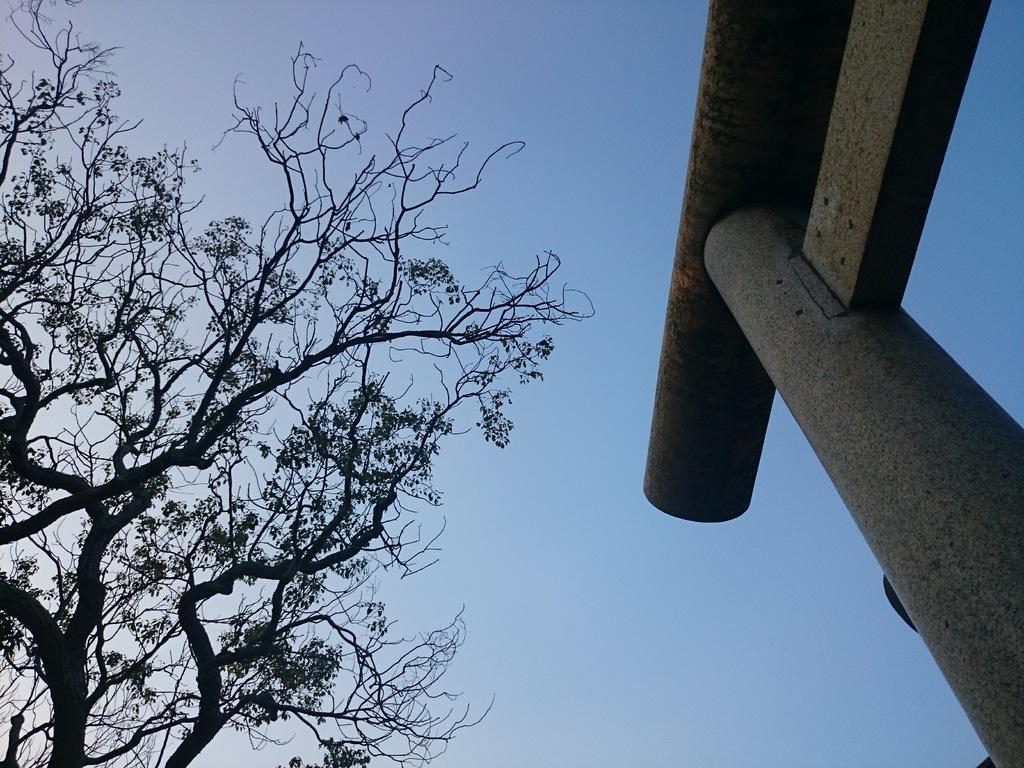How would you summarize this image in a sentence or two? On the right side of the image there is a pillar. On the left there is a tree. In the background we can see sky. 